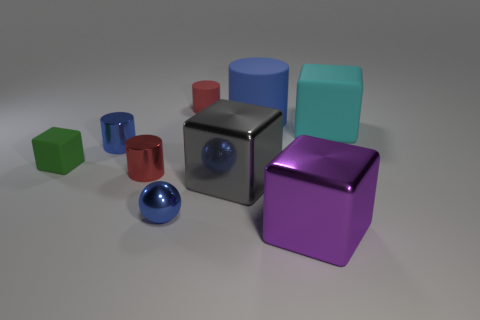There is a small cylinder to the left of the red shiny cylinder; is its color the same as the ball?
Your response must be concise. Yes. What shape is the tiny blue thing that is right of the small red object that is in front of the red object behind the small green matte thing?
Your answer should be very brief. Sphere. Does the blue shiny cylinder have the same size as the shiny block that is in front of the blue ball?
Ensure brevity in your answer.  No. Is there a metal sphere of the same size as the gray metal object?
Keep it short and to the point. No. How many other objects are the same material as the large blue cylinder?
Give a very brief answer. 3. What is the color of the cylinder that is both behind the small rubber block and to the left of the red rubber thing?
Ensure brevity in your answer.  Blue. Are the tiny blue object in front of the small blue shiny cylinder and the big block in front of the gray metallic cube made of the same material?
Your answer should be very brief. Yes. There is a matte block to the left of the cyan thing; does it have the same size as the purple shiny block?
Offer a very short reply. No. There is a small matte cube; does it have the same color as the tiny thing in front of the gray block?
Ensure brevity in your answer.  No. What shape is the metal thing that is the same color as the small metallic ball?
Make the answer very short. Cylinder. 